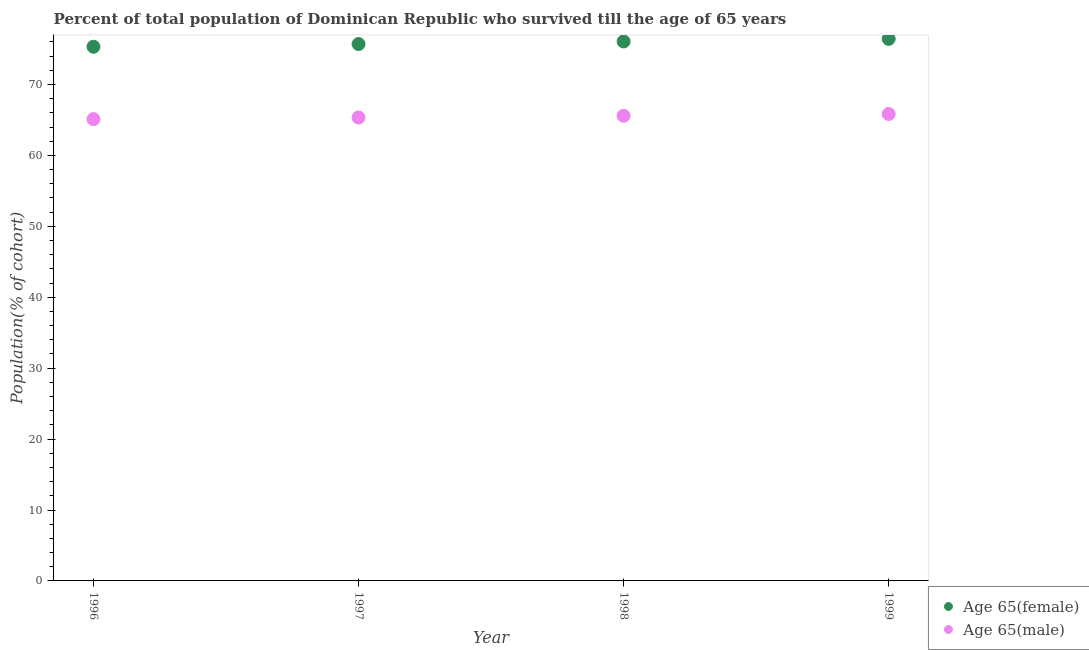What is the percentage of male population who survived till age of 65 in 1998?
Provide a short and direct response. 65.59. Across all years, what is the maximum percentage of female population who survived till age of 65?
Give a very brief answer. 76.44. Across all years, what is the minimum percentage of female population who survived till age of 65?
Your response must be concise. 75.33. In which year was the percentage of male population who survived till age of 65 minimum?
Provide a short and direct response. 1996. What is the total percentage of male population who survived till age of 65 in the graph?
Give a very brief answer. 261.9. What is the difference between the percentage of female population who survived till age of 65 in 1998 and that in 1999?
Your response must be concise. -0.36. What is the difference between the percentage of male population who survived till age of 65 in 1997 and the percentage of female population who survived till age of 65 in 1996?
Your answer should be compact. -9.98. What is the average percentage of female population who survived till age of 65 per year?
Your answer should be very brief. 75.89. In the year 1996, what is the difference between the percentage of male population who survived till age of 65 and percentage of female population who survived till age of 65?
Ensure brevity in your answer.  -10.21. In how many years, is the percentage of female population who survived till age of 65 greater than 72 %?
Give a very brief answer. 4. What is the ratio of the percentage of male population who survived till age of 65 in 1998 to that in 1999?
Offer a very short reply. 1. What is the difference between the highest and the second highest percentage of male population who survived till age of 65?
Provide a short and direct response. 0.25. What is the difference between the highest and the lowest percentage of male population who survived till age of 65?
Ensure brevity in your answer.  0.72. Is the sum of the percentage of female population who survived till age of 65 in 1997 and 1998 greater than the maximum percentage of male population who survived till age of 65 across all years?
Make the answer very short. Yes. Does the percentage of female population who survived till age of 65 monotonically increase over the years?
Provide a short and direct response. Yes. Is the percentage of male population who survived till age of 65 strictly greater than the percentage of female population who survived till age of 65 over the years?
Give a very brief answer. No. How many dotlines are there?
Give a very brief answer. 2. How many years are there in the graph?
Offer a very short reply. 4. What is the difference between two consecutive major ticks on the Y-axis?
Your answer should be compact. 10. Are the values on the major ticks of Y-axis written in scientific E-notation?
Your response must be concise. No. Does the graph contain any zero values?
Give a very brief answer. No. Where does the legend appear in the graph?
Provide a short and direct response. Bottom right. What is the title of the graph?
Offer a terse response. Percent of total population of Dominican Republic who survived till the age of 65 years. What is the label or title of the Y-axis?
Your answer should be very brief. Population(% of cohort). What is the Population(% of cohort) of Age 65(female) in 1996?
Your answer should be very brief. 75.33. What is the Population(% of cohort) in Age 65(male) in 1996?
Your response must be concise. 65.12. What is the Population(% of cohort) in Age 65(female) in 1997?
Give a very brief answer. 75.71. What is the Population(% of cohort) of Age 65(male) in 1997?
Give a very brief answer. 65.34. What is the Population(% of cohort) of Age 65(female) in 1998?
Your answer should be very brief. 76.07. What is the Population(% of cohort) in Age 65(male) in 1998?
Offer a very short reply. 65.59. What is the Population(% of cohort) of Age 65(female) in 1999?
Provide a short and direct response. 76.44. What is the Population(% of cohort) of Age 65(male) in 1999?
Provide a succinct answer. 65.84. Across all years, what is the maximum Population(% of cohort) in Age 65(female)?
Offer a very short reply. 76.44. Across all years, what is the maximum Population(% of cohort) in Age 65(male)?
Make the answer very short. 65.84. Across all years, what is the minimum Population(% of cohort) of Age 65(female)?
Your response must be concise. 75.33. Across all years, what is the minimum Population(% of cohort) of Age 65(male)?
Provide a short and direct response. 65.12. What is the total Population(% of cohort) in Age 65(female) in the graph?
Your answer should be compact. 303.54. What is the total Population(% of cohort) of Age 65(male) in the graph?
Your response must be concise. 261.9. What is the difference between the Population(% of cohort) of Age 65(female) in 1996 and that in 1997?
Your answer should be compact. -0.38. What is the difference between the Population(% of cohort) of Age 65(male) in 1996 and that in 1997?
Offer a very short reply. -0.22. What is the difference between the Population(% of cohort) in Age 65(female) in 1996 and that in 1998?
Your response must be concise. -0.74. What is the difference between the Population(% of cohort) in Age 65(male) in 1996 and that in 1998?
Your answer should be very brief. -0.47. What is the difference between the Population(% of cohort) of Age 65(female) in 1996 and that in 1999?
Give a very brief answer. -1.11. What is the difference between the Population(% of cohort) in Age 65(male) in 1996 and that in 1999?
Offer a terse response. -0.72. What is the difference between the Population(% of cohort) in Age 65(female) in 1997 and that in 1998?
Your answer should be very brief. -0.36. What is the difference between the Population(% of cohort) of Age 65(male) in 1997 and that in 1998?
Provide a short and direct response. -0.25. What is the difference between the Population(% of cohort) in Age 65(female) in 1997 and that in 1999?
Keep it short and to the point. -0.73. What is the difference between the Population(% of cohort) of Age 65(male) in 1997 and that in 1999?
Provide a short and direct response. -0.5. What is the difference between the Population(% of cohort) of Age 65(female) in 1998 and that in 1999?
Provide a succinct answer. -0.36. What is the difference between the Population(% of cohort) in Age 65(male) in 1998 and that in 1999?
Provide a succinct answer. -0.25. What is the difference between the Population(% of cohort) in Age 65(female) in 1996 and the Population(% of cohort) in Age 65(male) in 1997?
Your response must be concise. 9.98. What is the difference between the Population(% of cohort) in Age 65(female) in 1996 and the Population(% of cohort) in Age 65(male) in 1998?
Offer a very short reply. 9.73. What is the difference between the Population(% of cohort) of Age 65(female) in 1996 and the Population(% of cohort) of Age 65(male) in 1999?
Your answer should be compact. 9.48. What is the difference between the Population(% of cohort) of Age 65(female) in 1997 and the Population(% of cohort) of Age 65(male) in 1998?
Offer a very short reply. 10.12. What is the difference between the Population(% of cohort) in Age 65(female) in 1997 and the Population(% of cohort) in Age 65(male) in 1999?
Ensure brevity in your answer.  9.87. What is the difference between the Population(% of cohort) in Age 65(female) in 1998 and the Population(% of cohort) in Age 65(male) in 1999?
Make the answer very short. 10.23. What is the average Population(% of cohort) in Age 65(female) per year?
Offer a terse response. 75.89. What is the average Population(% of cohort) of Age 65(male) per year?
Provide a succinct answer. 65.48. In the year 1996, what is the difference between the Population(% of cohort) of Age 65(female) and Population(% of cohort) of Age 65(male)?
Offer a terse response. 10.21. In the year 1997, what is the difference between the Population(% of cohort) in Age 65(female) and Population(% of cohort) in Age 65(male)?
Provide a succinct answer. 10.36. In the year 1998, what is the difference between the Population(% of cohort) of Age 65(female) and Population(% of cohort) of Age 65(male)?
Give a very brief answer. 10.48. In the year 1999, what is the difference between the Population(% of cohort) of Age 65(female) and Population(% of cohort) of Age 65(male)?
Ensure brevity in your answer.  10.59. What is the ratio of the Population(% of cohort) of Age 65(female) in 1996 to that in 1998?
Offer a very short reply. 0.99. What is the ratio of the Population(% of cohort) of Age 65(female) in 1996 to that in 1999?
Ensure brevity in your answer.  0.99. What is the ratio of the Population(% of cohort) of Age 65(male) in 1997 to that in 1998?
Your answer should be very brief. 1. What is the difference between the highest and the second highest Population(% of cohort) of Age 65(female)?
Offer a very short reply. 0.36. What is the difference between the highest and the second highest Population(% of cohort) of Age 65(male)?
Provide a short and direct response. 0.25. What is the difference between the highest and the lowest Population(% of cohort) in Age 65(female)?
Keep it short and to the point. 1.11. What is the difference between the highest and the lowest Population(% of cohort) in Age 65(male)?
Provide a succinct answer. 0.72. 